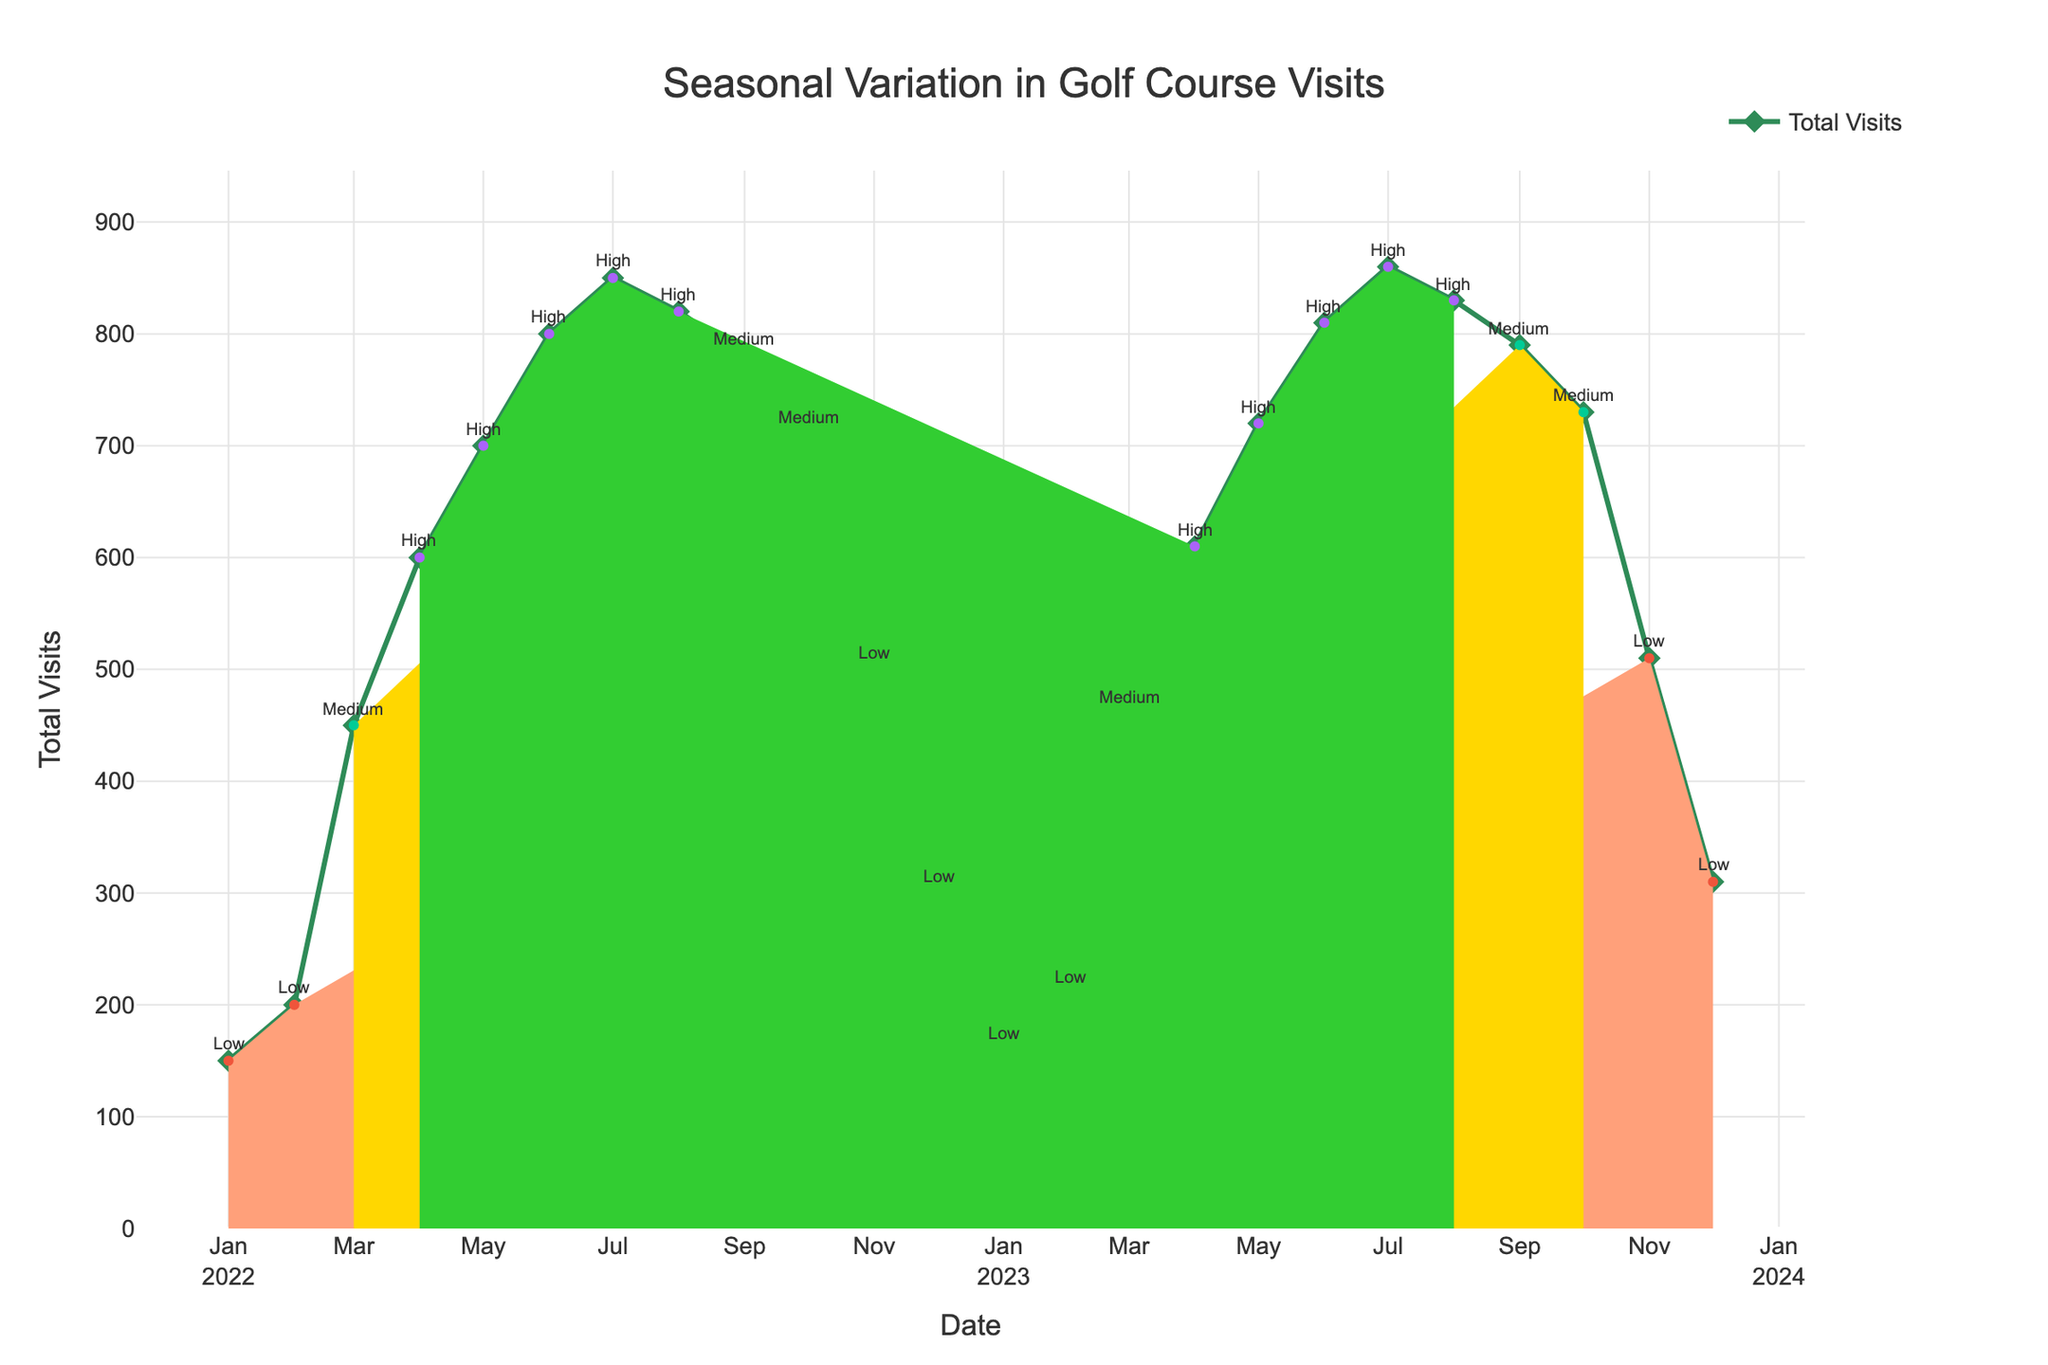What is the title of the figure? The title is located at the top center of the figure. By reading it, one can identify the main subject of the plot.
Answer: "Seasonal Variation in Golf Course Visits" How many data points are there for each year? The x-axis is marked with dates. By counting the number of date points within each year, we find that there are 12 data points for each year (one for each month).
Answer: 12 What is the highest number of visits recorded, and in which month does it occur? By observing the y-axis and the peaks in the line graph, we see that the highest point is 860 visits. The corresponding date on the x-axis is July 2023.
Answer: 860 visits in July 2023 How does the total number of visits change from January to December each year? By following the trend line from January to December, we can see that visits generally increase during the summer months before declining towards the end of the year. This pattern occurs in both 2022 and 2023.
Answer: Increases, then decreases During which periods is the Professional Tour Influence categorized as 'High'? By looking at the colored areas along the line plot, we can see the 'High' influence is indicated using a specific color (green). It corresponds to April through August for both years.
Answer: April to August Calculate the total visits for the months classified as 'Medium' influence for 2023. Identify the months labeled 'Medium' (March, September, October) and sum their corresponding values (460 + 790 + 730). This results in the total number of visits for those months.
Answer: 1980 Which month has the lowest number of visits, and how many are there? By examining the line graph to find the lowest point, we see it is in January 2022, with 150 visits. This is cross-referenced with the x-axis for the date.
Answer: January 2022 with 150 visits Compare the total number of visits in May for 2022 and 2023. Which year had more visits? Check the y-axis values for May 2022 (700 visits) and May 2023 (720 visits). The result shows a small increase in visits from 2022 to 2023.
Answer: 2023 with 720 visits In which month do visits start to increase significantly each year? By observing the trend, visits start to increase notably around March for both years, corresponding to the beginning of 'Medium' influence periods.
Answer: March What's the difference in total visits between the highest and lowest months in 2023? The highest visits in 2023 occur in July (860 visits), while the lowest are in January (160 visits). Subtracting these two numbers gives the difference (860 - 160 = 700).
Answer: 700 visits 